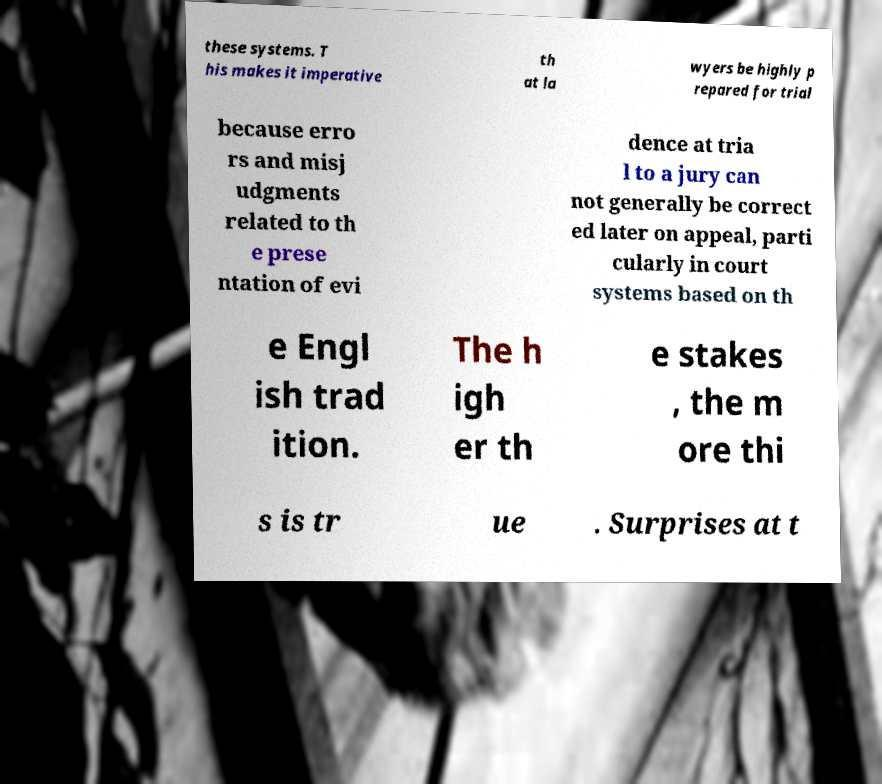Please read and relay the text visible in this image. What does it say? these systems. T his makes it imperative th at la wyers be highly p repared for trial because erro rs and misj udgments related to th e prese ntation of evi dence at tria l to a jury can not generally be correct ed later on appeal, parti cularly in court systems based on th e Engl ish trad ition. The h igh er th e stakes , the m ore thi s is tr ue . Surprises at t 